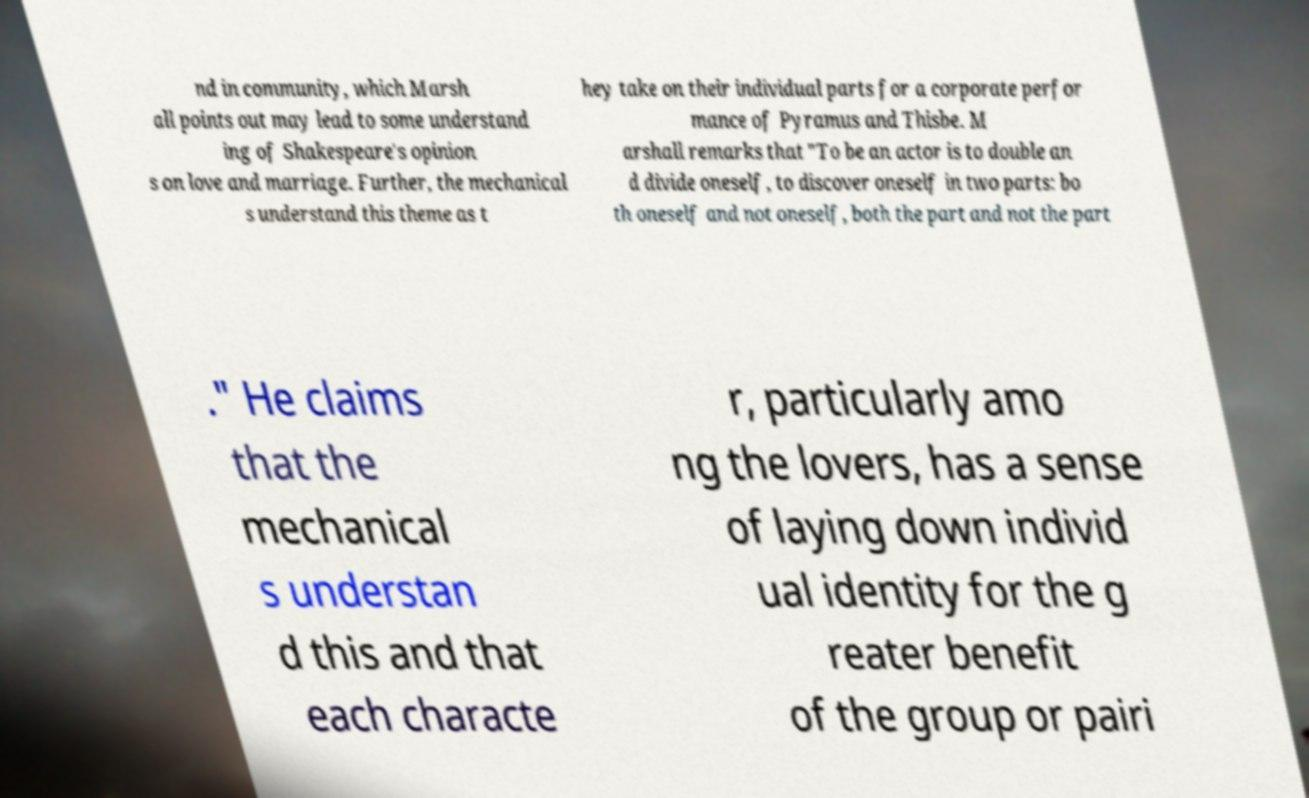For documentation purposes, I need the text within this image transcribed. Could you provide that? nd in community, which Marsh all points out may lead to some understand ing of Shakespeare's opinion s on love and marriage. Further, the mechanical s understand this theme as t hey take on their individual parts for a corporate perfor mance of Pyramus and Thisbe. M arshall remarks that "To be an actor is to double an d divide oneself, to discover oneself in two parts: bo th oneself and not oneself, both the part and not the part ." He claims that the mechanical s understan d this and that each characte r, particularly amo ng the lovers, has a sense of laying down individ ual identity for the g reater benefit of the group or pairi 